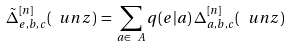Convert formula to latex. <formula><loc_0><loc_0><loc_500><loc_500>\tilde { \Delta } ^ { [ n ] } _ { e , b , c } ( \ u n { z } ) \, = \, \sum _ { a \in \ A } q ( e | a ) \, \Delta ^ { [ n ] } _ { a , b , c } ( \ u n { z } )</formula> 